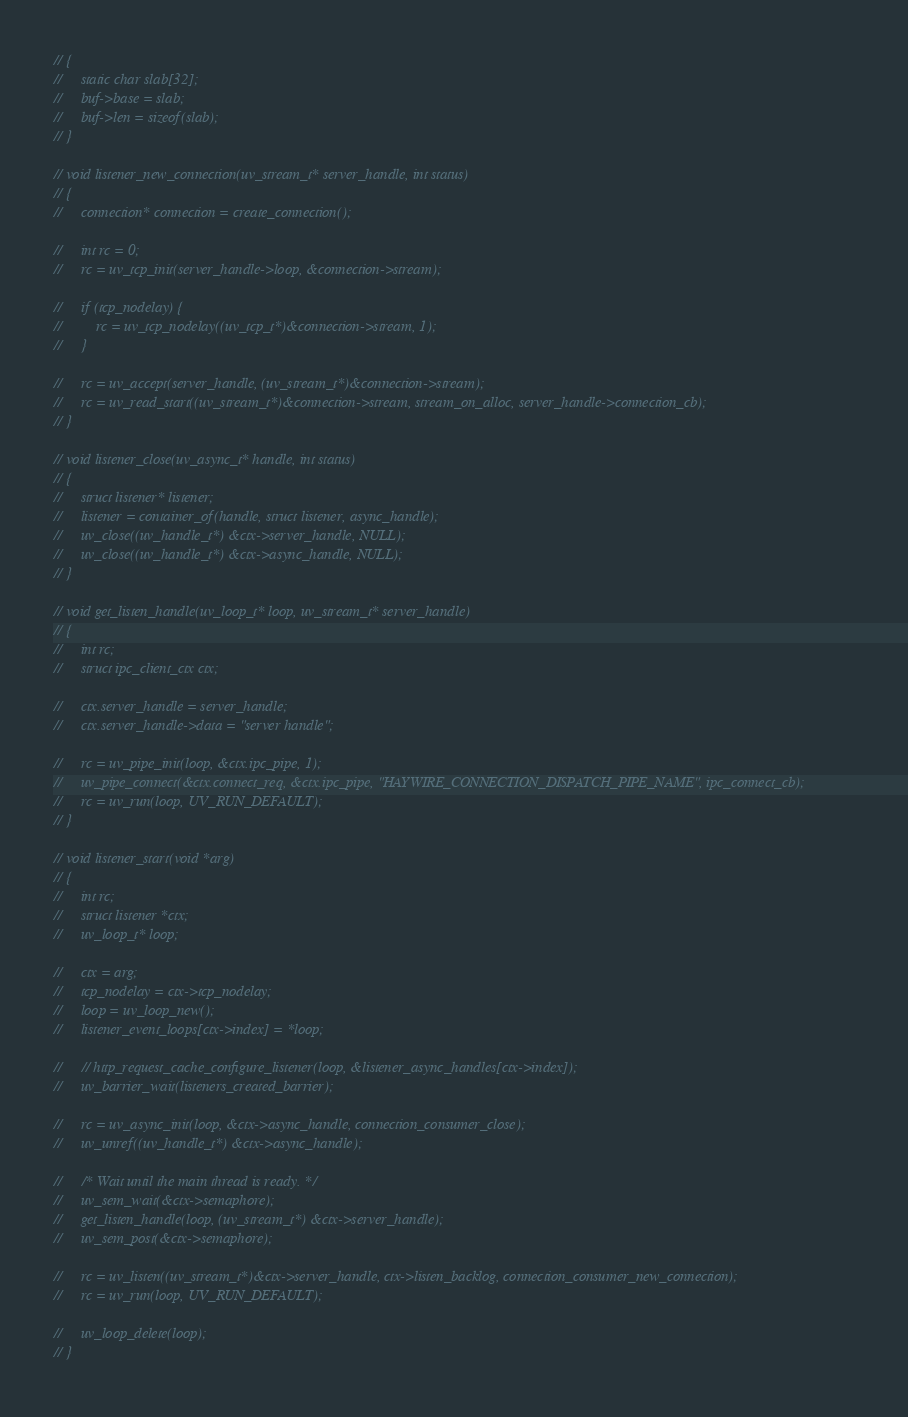<code> <loc_0><loc_0><loc_500><loc_500><_C_>// {
//     static char slab[32];
//     buf->base = slab;
//     buf->len = sizeof(slab);
// }

// void listener_new_connection(uv_stream_t* server_handle, int status)
// {
//     connection* connection = create_connection();

//     int rc = 0;
//     rc = uv_tcp_init(server_handle->loop, &connection->stream);
    
//     if (tcp_nodelay) {
//         rc = uv_tcp_nodelay((uv_tcp_t*)&connection->stream, 1);
//     }

//     rc = uv_accept(server_handle, (uv_stream_t*)&connection->stream);
//     rc = uv_read_start((uv_stream_t*)&connection->stream, stream_on_alloc, server_handle->connection_cb);
// }

// void listener_close(uv_async_t* handle, int status)
// {
//     struct listener* listener;
//     listener = container_of(handle, struct listener, async_handle);
//     uv_close((uv_handle_t*) &ctx->server_handle, NULL);
//     uv_close((uv_handle_t*) &ctx->async_handle, NULL);
// }

// void get_listen_handle(uv_loop_t* loop, uv_stream_t* server_handle)
// {
//     int rc;
//     struct ipc_client_ctx ctx;
    
//     ctx.server_handle = server_handle;
//     ctx.server_handle->data = "server handle";
    
//     rc = uv_pipe_init(loop, &ctx.ipc_pipe, 1);
//     uv_pipe_connect(&ctx.connect_req, &ctx.ipc_pipe, "HAYWIRE_CONNECTION_DISPATCH_PIPE_NAME", ipc_connect_cb);
//     rc = uv_run(loop, UV_RUN_DEFAULT);
// }

// void listener_start(void *arg)
// {
//     int rc;
//     struct listener *ctx;
//     uv_loop_t* loop;
    
//     ctx = arg;
//     tcp_nodelay = ctx->tcp_nodelay;
//     loop = uv_loop_new();
//     listener_event_loops[ctx->index] = *loop;
    
//     // http_request_cache_configure_listener(loop, &listener_async_handles[ctx->index]);
//     uv_barrier_wait(listeners_created_barrier);
    
//     rc = uv_async_init(loop, &ctx->async_handle, connection_consumer_close);
//     uv_unref((uv_handle_t*) &ctx->async_handle);
    
//     /* Wait until the main thread is ready. */
//     uv_sem_wait(&ctx->semaphore);
//     get_listen_handle(loop, (uv_stream_t*) &ctx->server_handle);
//     uv_sem_post(&ctx->semaphore);
    
//     rc = uv_listen((uv_stream_t*)&ctx->server_handle, ctx->listen_backlog, connection_consumer_new_connection);
//     rc = uv_run(loop, UV_RUN_DEFAULT);
    
//     uv_loop_delete(loop);
// }
</code> 